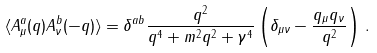<formula> <loc_0><loc_0><loc_500><loc_500>\langle { A _ { \mu } ^ { a } ( q ) A _ { \nu } ^ { b } ( - q ) } \rangle = \delta ^ { a b } \frac { q ^ { 2 } } { q ^ { 4 } + m ^ { 2 } q ^ { 2 } + \gamma ^ { 4 } } \left ( \delta _ { \mu \nu } - \frac { q _ { \mu } { q } _ { \nu } } { q ^ { 2 } } \right ) \, .</formula> 